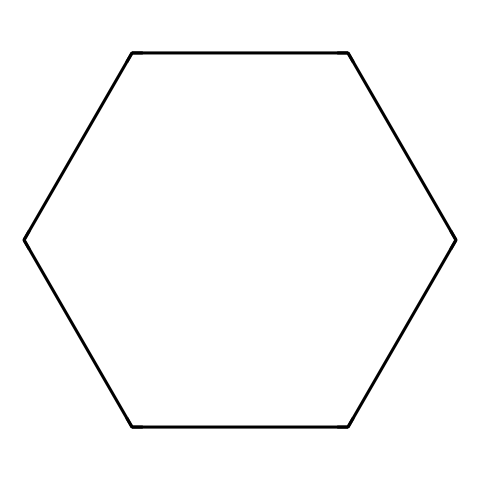What is the molecular formula of cyclohexane? Cyclohexane's structure consists of six carbon atoms, with each carbon forming two bonds to adjacent carbons, creating a closed ring, and two bonds to hydrogen atoms. Thus, the formula is derived from six carbons and twelve hydrogens.
Answer: C6H12 How many hydrogen atoms are bonded to each carbon atom in cyclohexane? In cyclohexane, each carbon atom is bonded to two adjacent carbon atoms and two hydrogen atoms, resulting in a total of two hydrogen atoms bonded to each carbon.
Answer: 2 What is the bond angle between the carbon atoms in cyclohexane? The ideal bond angle for cyclohexane is approximately 109.5 degrees, corresponding to the tetrahedral geometry of the sp3 hybridized carbons in a cycloalkane structure.
Answer: 109.5 degrees What type of hydrocarbon is cyclohexane? Cyclohexane is classified as a cycloalkane due to its cyclic structure and saturated carbon-carbon bonds, which is a defining characteristic of cycloalkanes.
Answer: cycloalkane How does cyclohexane's physical state compare to low molecular weight alkanes? Cyclohexane is a liquid at room temperature, similar to other low molecular weight alkanes such as hexane and heptane, but its boiling and melting points are generally higher than those of straight-chain alkanes with similar carbon counts due to ring strain characteristics.
Answer: liquid What property allows cyclohexane to be used as a solvent? Cyclohexane's nonpolar nature allows it to effectively dissolve a wide range of nonpolar and hydrophobic compounds, making it a suitable solvent for various industrial cleaning applications.
Answer: nonpolar 